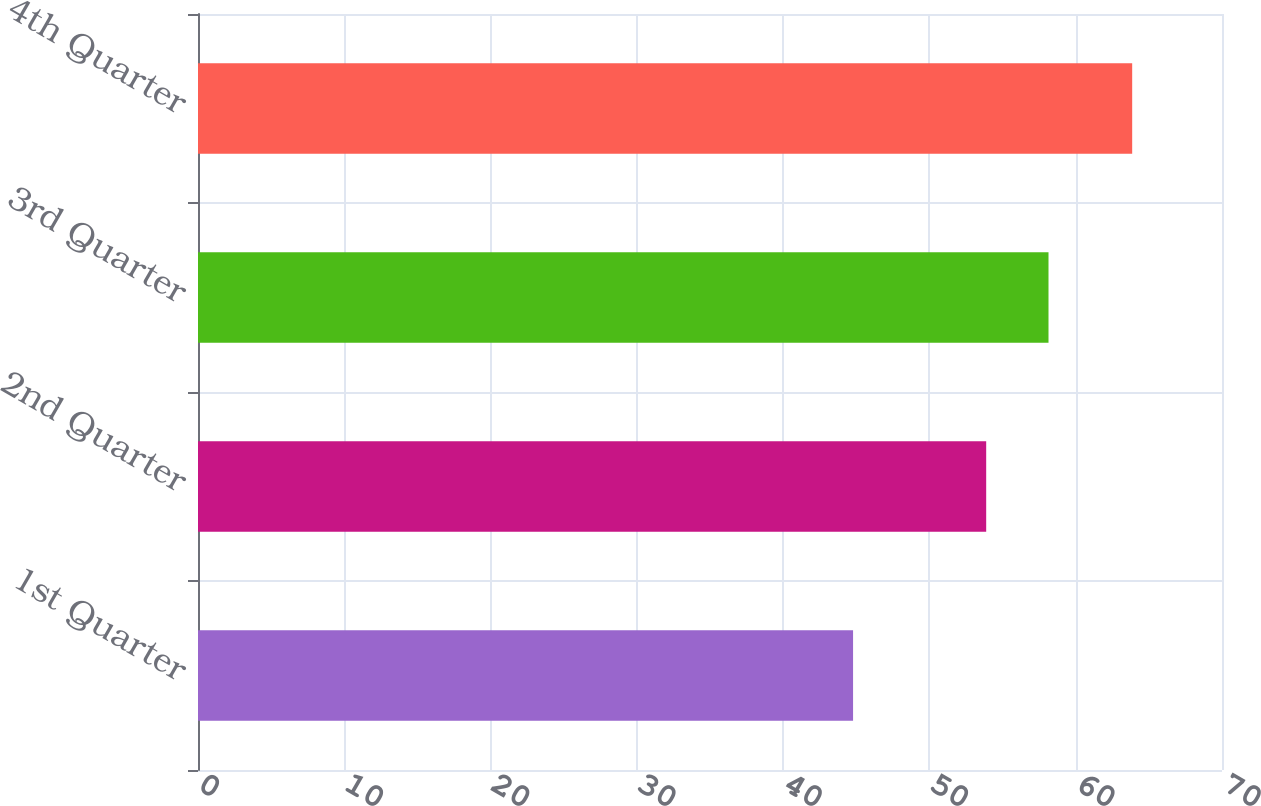<chart> <loc_0><loc_0><loc_500><loc_500><bar_chart><fcel>1st Quarter<fcel>2nd Quarter<fcel>3rd Quarter<fcel>4th Quarter<nl><fcel>44.78<fcel>53.88<fcel>58.14<fcel>63.86<nl></chart> 